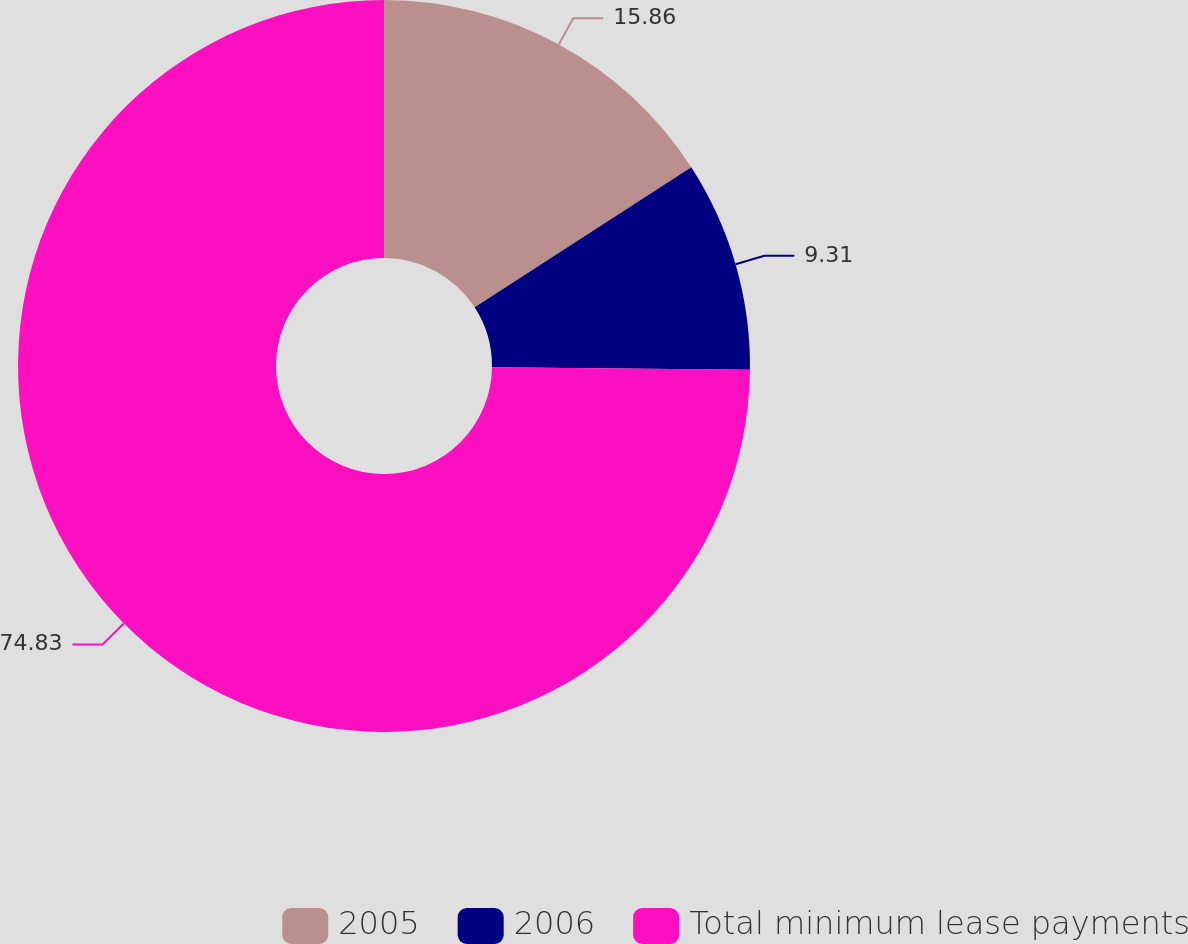Convert chart to OTSL. <chart><loc_0><loc_0><loc_500><loc_500><pie_chart><fcel>2005<fcel>2006<fcel>Total minimum lease payments<nl><fcel>15.86%<fcel>9.31%<fcel>74.84%<nl></chart> 